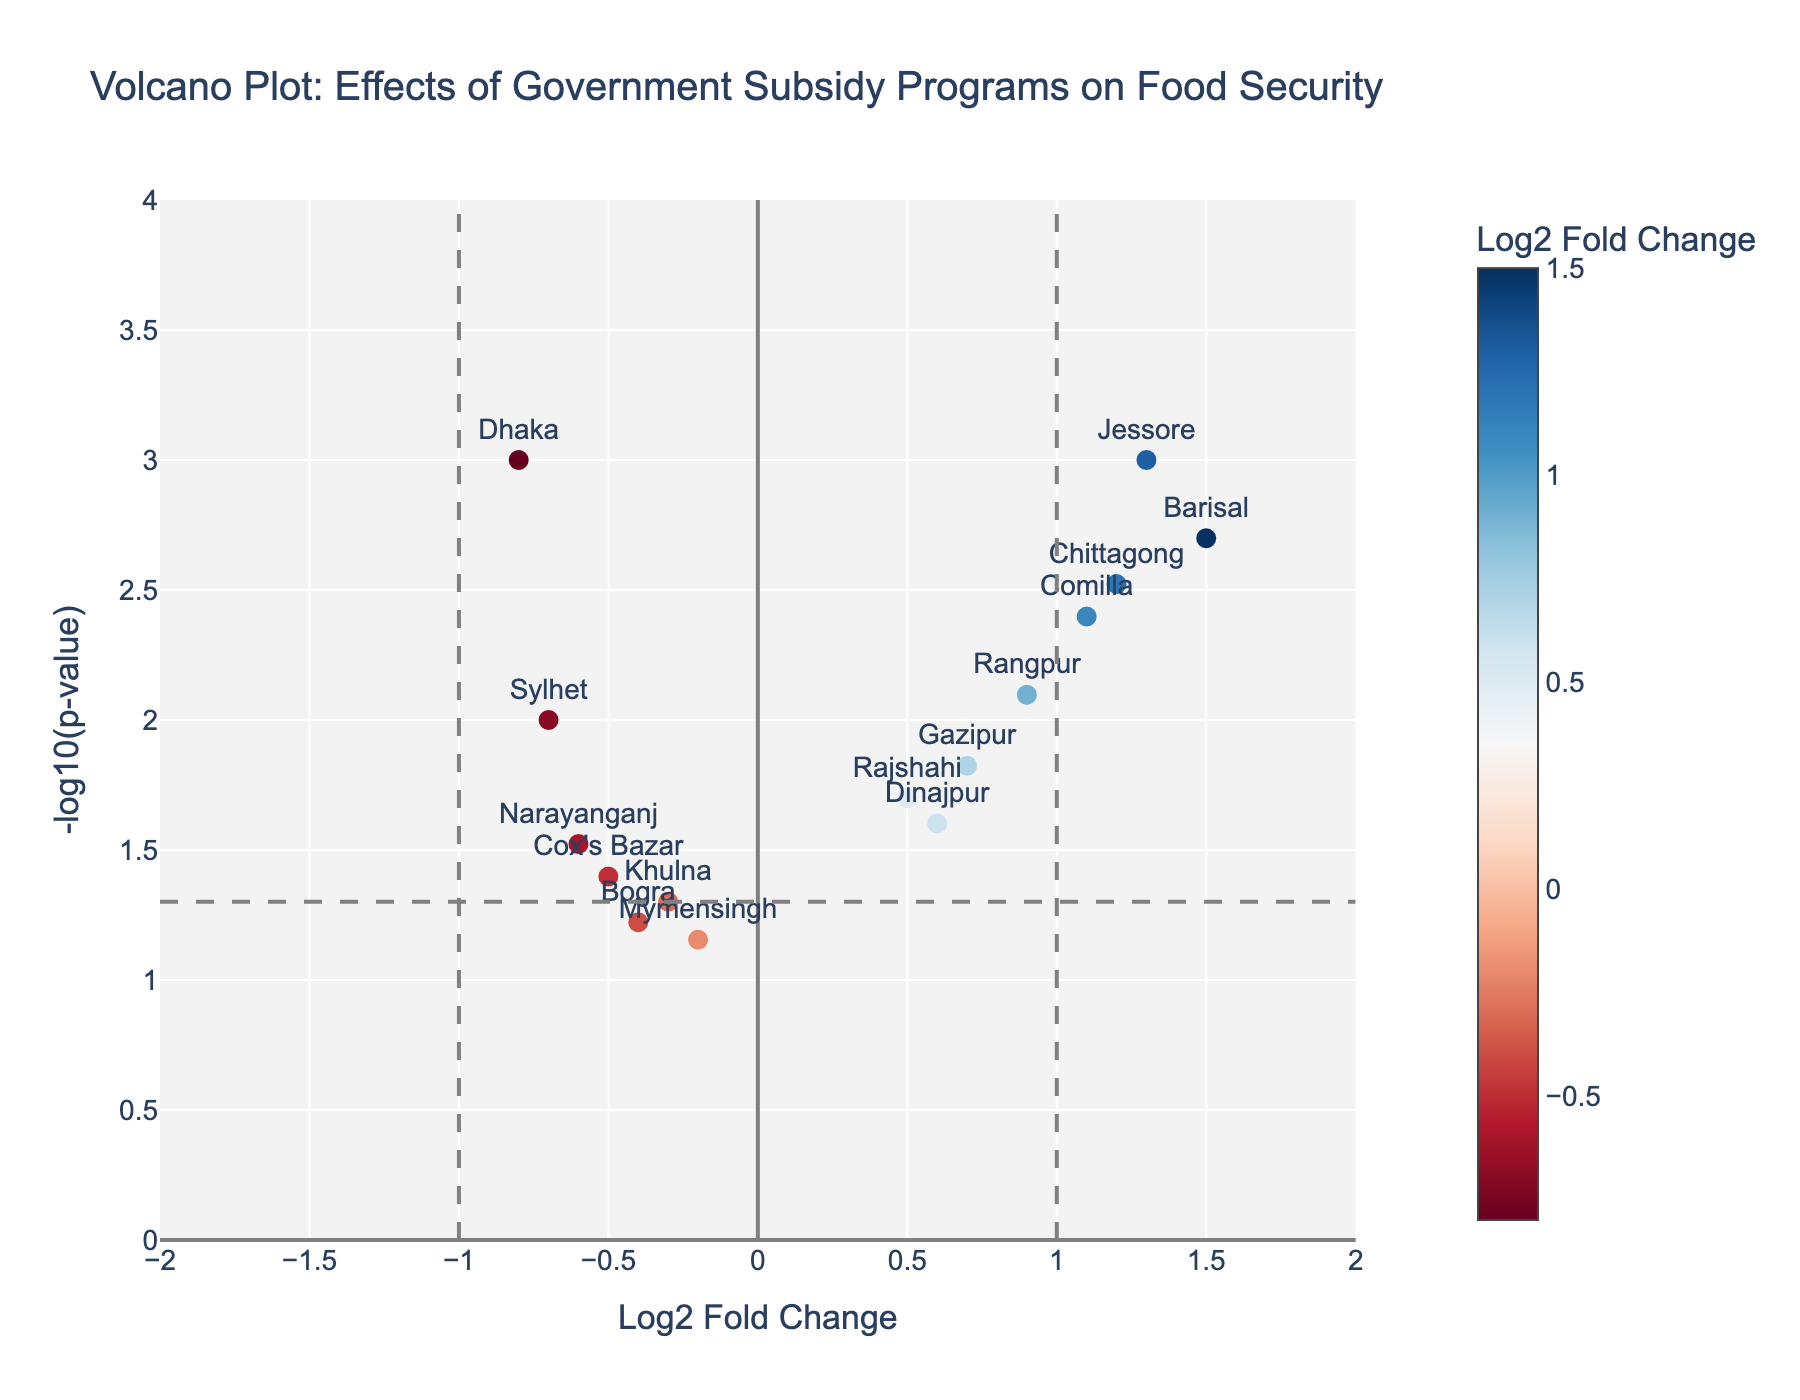What is the title of the plot? The title is positioned at the top of the figure and provides a summary of what the plot is about.
Answer: Volcano Plot: Effects of Government Subsidy Programs on Food Security How many data points are there in the plot? Each marker represents a district, and there are 15 districts labeled on the figure.
Answer: 15 Which district has the highest log2 fold change? By finding the highest point on the x-axis, we see the marker labeled "Barisal" at 1.5.
Answer: Barisal Which districts have a significant p-value less than 0.05 and a negative log2 fold change? Looking for points below the p-value threshold line with colors corresponding to negative log2 fold changes, we find Dhaka, Sylhet, and Narayanganj.
Answer: Dhaka, Sylhet, Narayanganj What is the log2 fold change for Chittagong, and is it significant? Hovering over the marker for Chittagong reveals its log2 fold change as 1.2 and a p-value of 0.003, which is less than 0.05, indicating significance.
Answer: 1.2, yes Compare the food security effects between Dhaka and Chittagong. Which is more negatively impacted? Looking at the log2 fold change, Dhaka (-0.8) shows a more negative impact than Chittagong (1.2).
Answer: Dhaka If a log2 fold change > 1 indicates a strong positive effect on food security, which districts meet this criterion? Districts with log2 fold changes greater than 1 are Chittagong, Barisal, Comilla, and Jessore.
Answer: Chittagong, Barisal, Comilla, Jessore Which district has the smallest p-value and what does this indicate about the statistical significance for that district? By identifying the smallest marker on the y-axis, we find Jessore with a p-value of 0.001, indicating very high statistical significance.
Answer: Jessore What color scale is used to indicate log2 fold change, and what range does it cover? The color scale ranges from blue for negative log2 fold changes to red for positive log2 fold changes, as indicated by the color bar.
Answer: Blue to Red How does the food security impact of Rangpur compare with that of Bogra? Rangpur has a positive log2 fold change (0.9) while Bogra has a negative one (-0.4), indicating that Rangpur is more positively impacted.
Answer: Rangpur is more positively impacted 